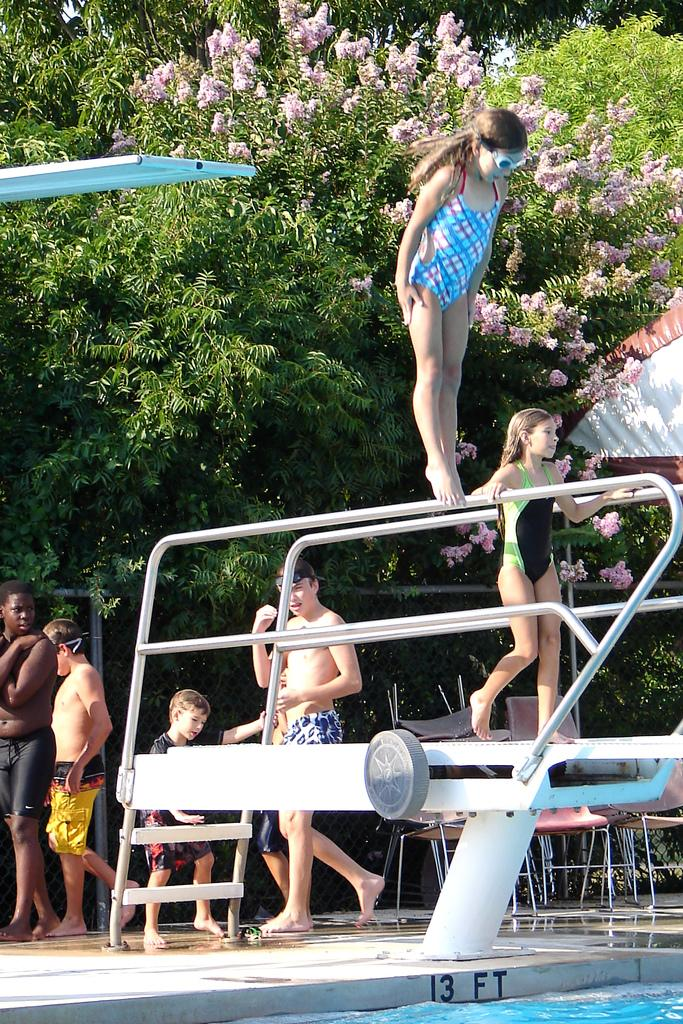What is present at the bottom of the image? There is water at the bottom of the image. Who or what can be seen in the image? There are people in the image. What can be seen in the distance in the image? There are trees and flowers in the background of the image. What type of addition problem can be solved using the railway tracks in the image? There are no railway tracks present in the image, so it is not possible to solve an addition problem using them. 